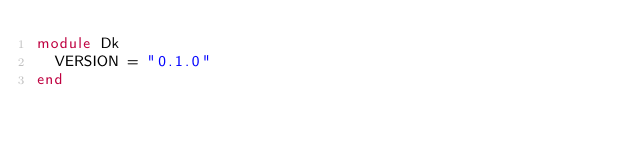<code> <loc_0><loc_0><loc_500><loc_500><_Crystal_>module Dk
  VERSION = "0.1.0"
end
</code> 